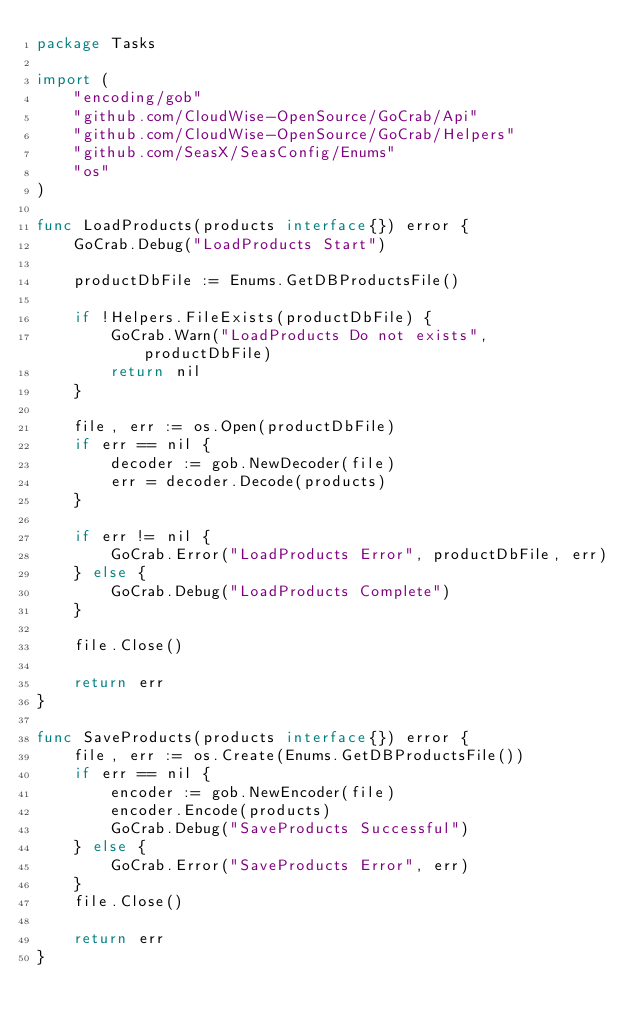Convert code to text. <code><loc_0><loc_0><loc_500><loc_500><_Go_>package Tasks

import (
	"encoding/gob"
	"github.com/CloudWise-OpenSource/GoCrab/Api"
	"github.com/CloudWise-OpenSource/GoCrab/Helpers"
	"github.com/SeasX/SeasConfig/Enums"
	"os"
)

func LoadProducts(products interface{}) error {
	GoCrab.Debug("LoadProducts Start")

	productDbFile := Enums.GetDBProductsFile()

	if !Helpers.FileExists(productDbFile) {
		GoCrab.Warn("LoadProducts Do not exists", productDbFile)
		return nil
	}

	file, err := os.Open(productDbFile)
	if err == nil {
		decoder := gob.NewDecoder(file)
		err = decoder.Decode(products)
	}

	if err != nil {
		GoCrab.Error("LoadProducts Error", productDbFile, err)
	} else {
		GoCrab.Debug("LoadProducts Complete")
	}

	file.Close()

	return err
}

func SaveProducts(products interface{}) error {
	file, err := os.Create(Enums.GetDBProductsFile())
	if err == nil {
		encoder := gob.NewEncoder(file)
		encoder.Encode(products)
		GoCrab.Debug("SaveProducts Successful")
	} else {
		GoCrab.Error("SaveProducts Error", err)
	}
	file.Close()

	return err
}
</code> 